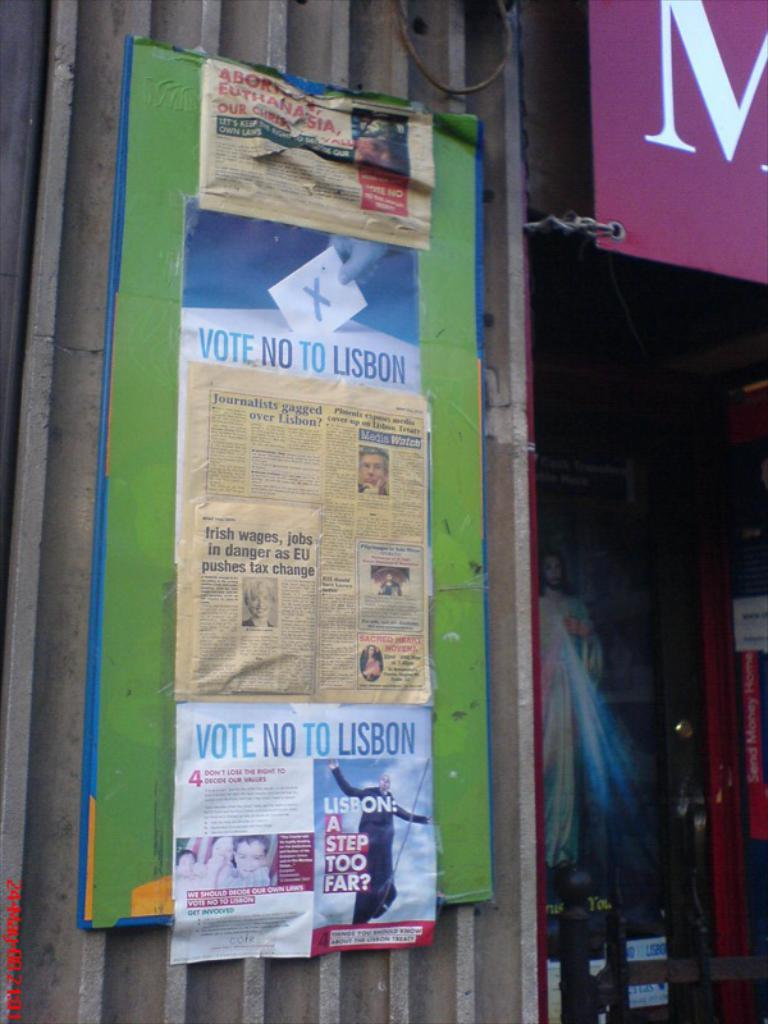Provide a one-sentence caption for the provided image. A flyer on a bulletin board outside a store that says Vote No To Lisbon on it. 